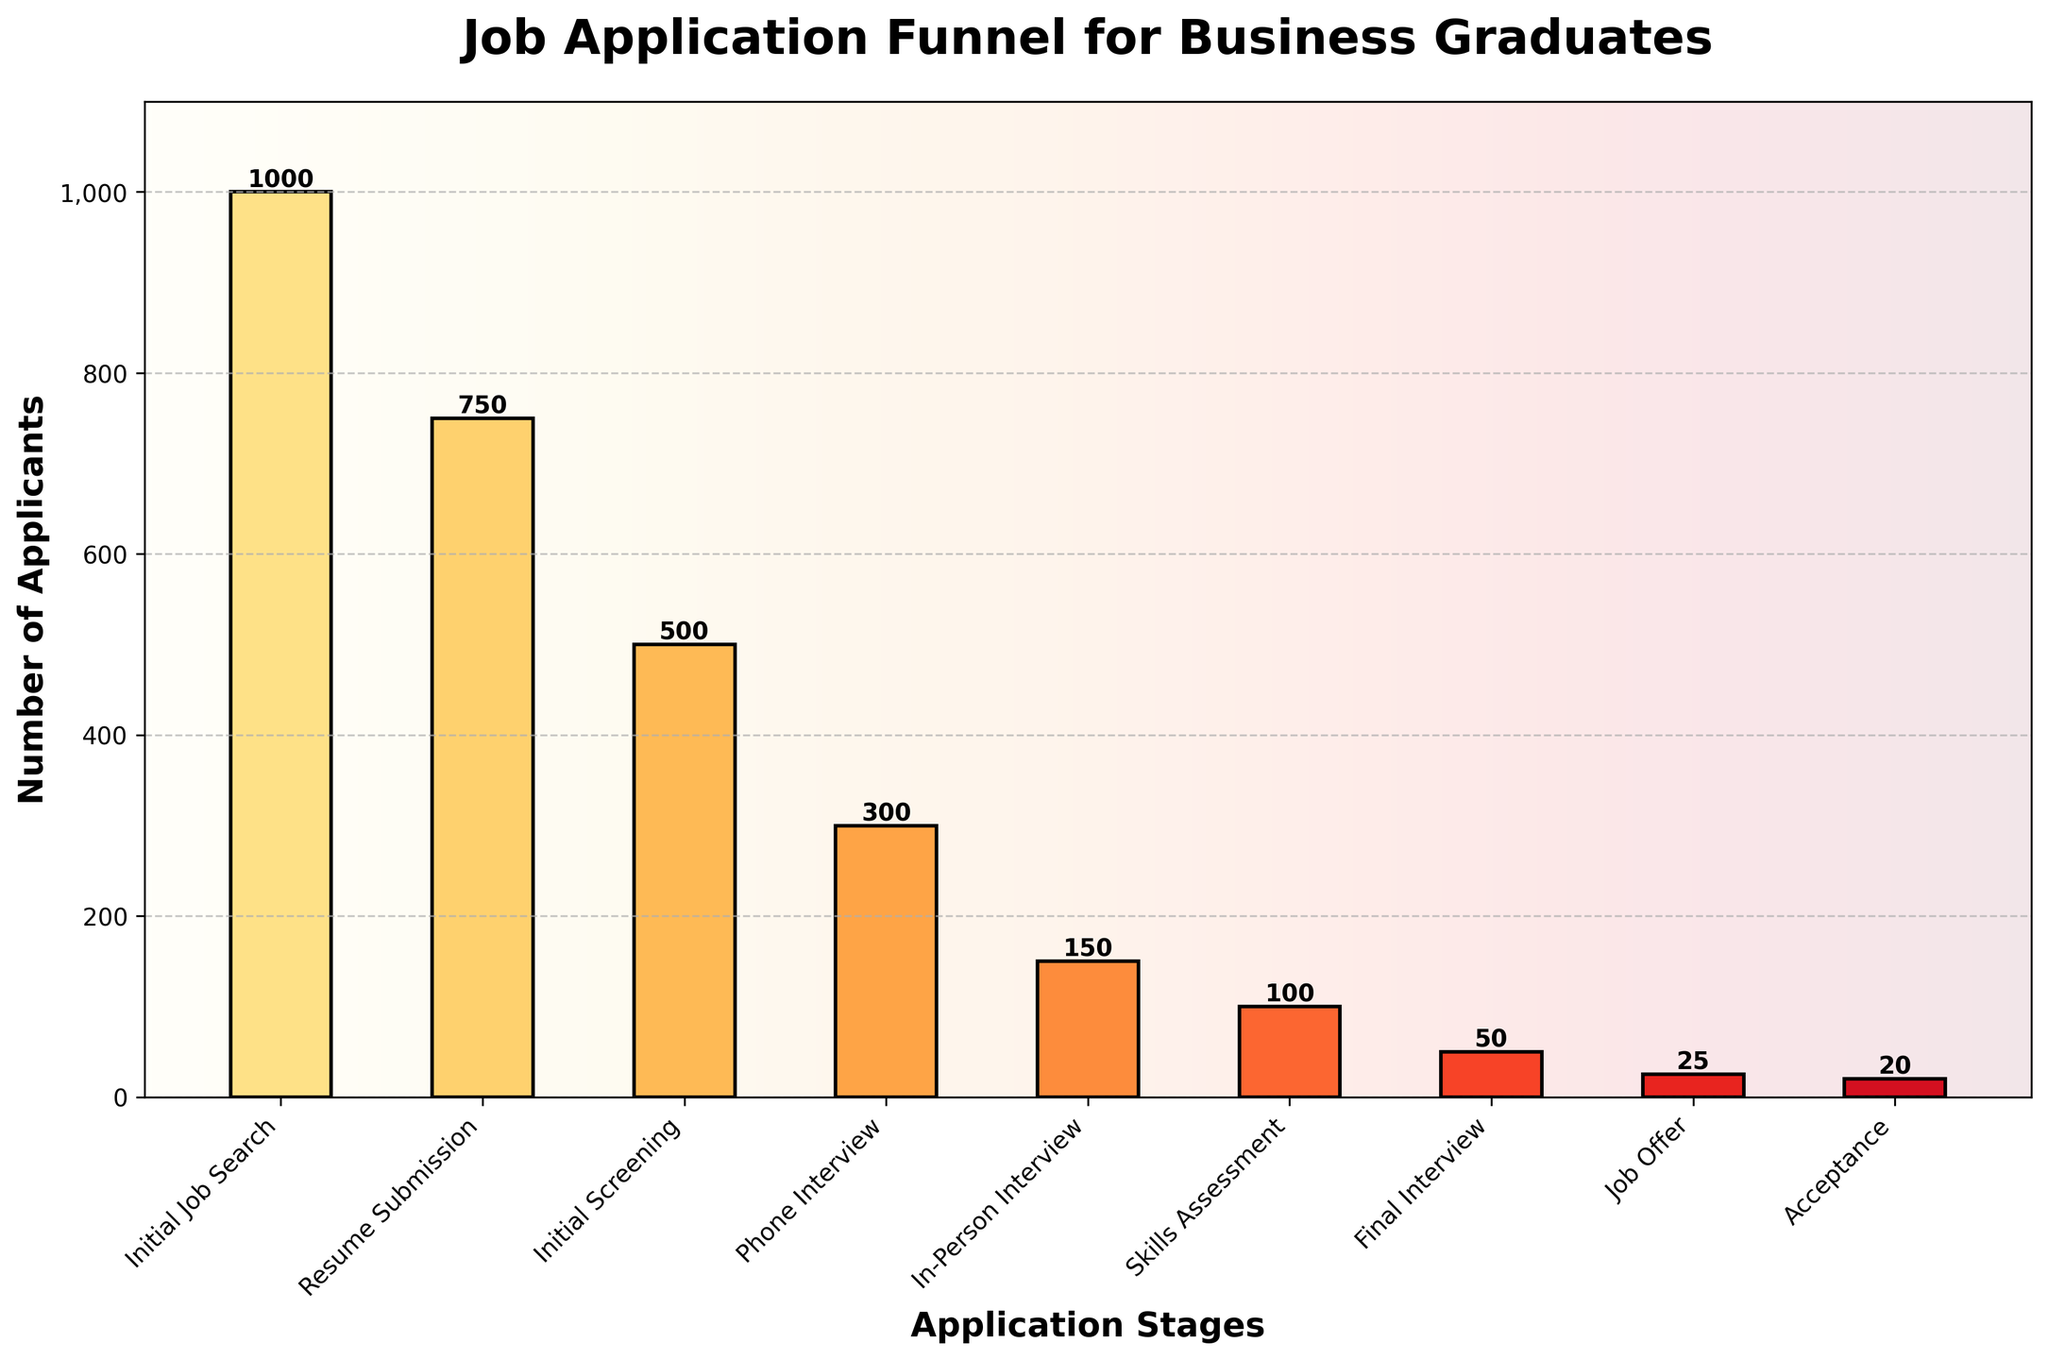How many stages are presented in the job application funnel? Count the number of distinct stages on the x-axis of the funnel chart.
Answer: 8 What is the title of the chart? Look at the top of the chart where the title is usually displayed.
Answer: Job Application Funnel for Business Graduates Which stage has the highest number of applicants? Identify the bar that reaches the highest point on the y-axis; this is the stage with the most applicants.
Answer: Initial Job Search Approximately what percentage of applicants move from Resume Submission to Initial Screening? The number of applicants at Resume Submission is 750 and at Initial Screening is 500. Calculate the percentage (500/750)*100.
Answer: 66.67% How many applicants are lost between the Phone Interview and In-Person Interview stages? Subtract the number of applicants at In-Person Interview (150) from those at Phone Interview (300).
Answer: 150 What differentiates the Skills Assessment stage in terms of number of applicants compared to the Final Interview stage? The number of applicants drops from 100 at Skills Assessment to 50 at Final Interview. Subtract 50 from 100 to find the difference.
Answer: 50 Which stage has the lowest number of applicants? Identify the bar that is the shortest on the y-axis; this is the stage with the fewest applicants.
Answer: Acceptance What is the total number of applicants who were offered a job and accepted it? The number of applicants in the Job Offer stage is 25 and the Acceptance stage is 20.
Answer: 20 What is the decrease in applicants from the In-Person Interview to the Skills Assessment? Subtract the number at Skills Assessment (100) from the number at In-Person Interview (150).
Answer: 50 Which two stages have the biggest drop in the number of applicants between them? Compare the decreases in the number of applicants between each stage; the largest difference is between Initial Screening (500) and Phone Interview (300).
Answer: Initial Screening to Phone Interview 